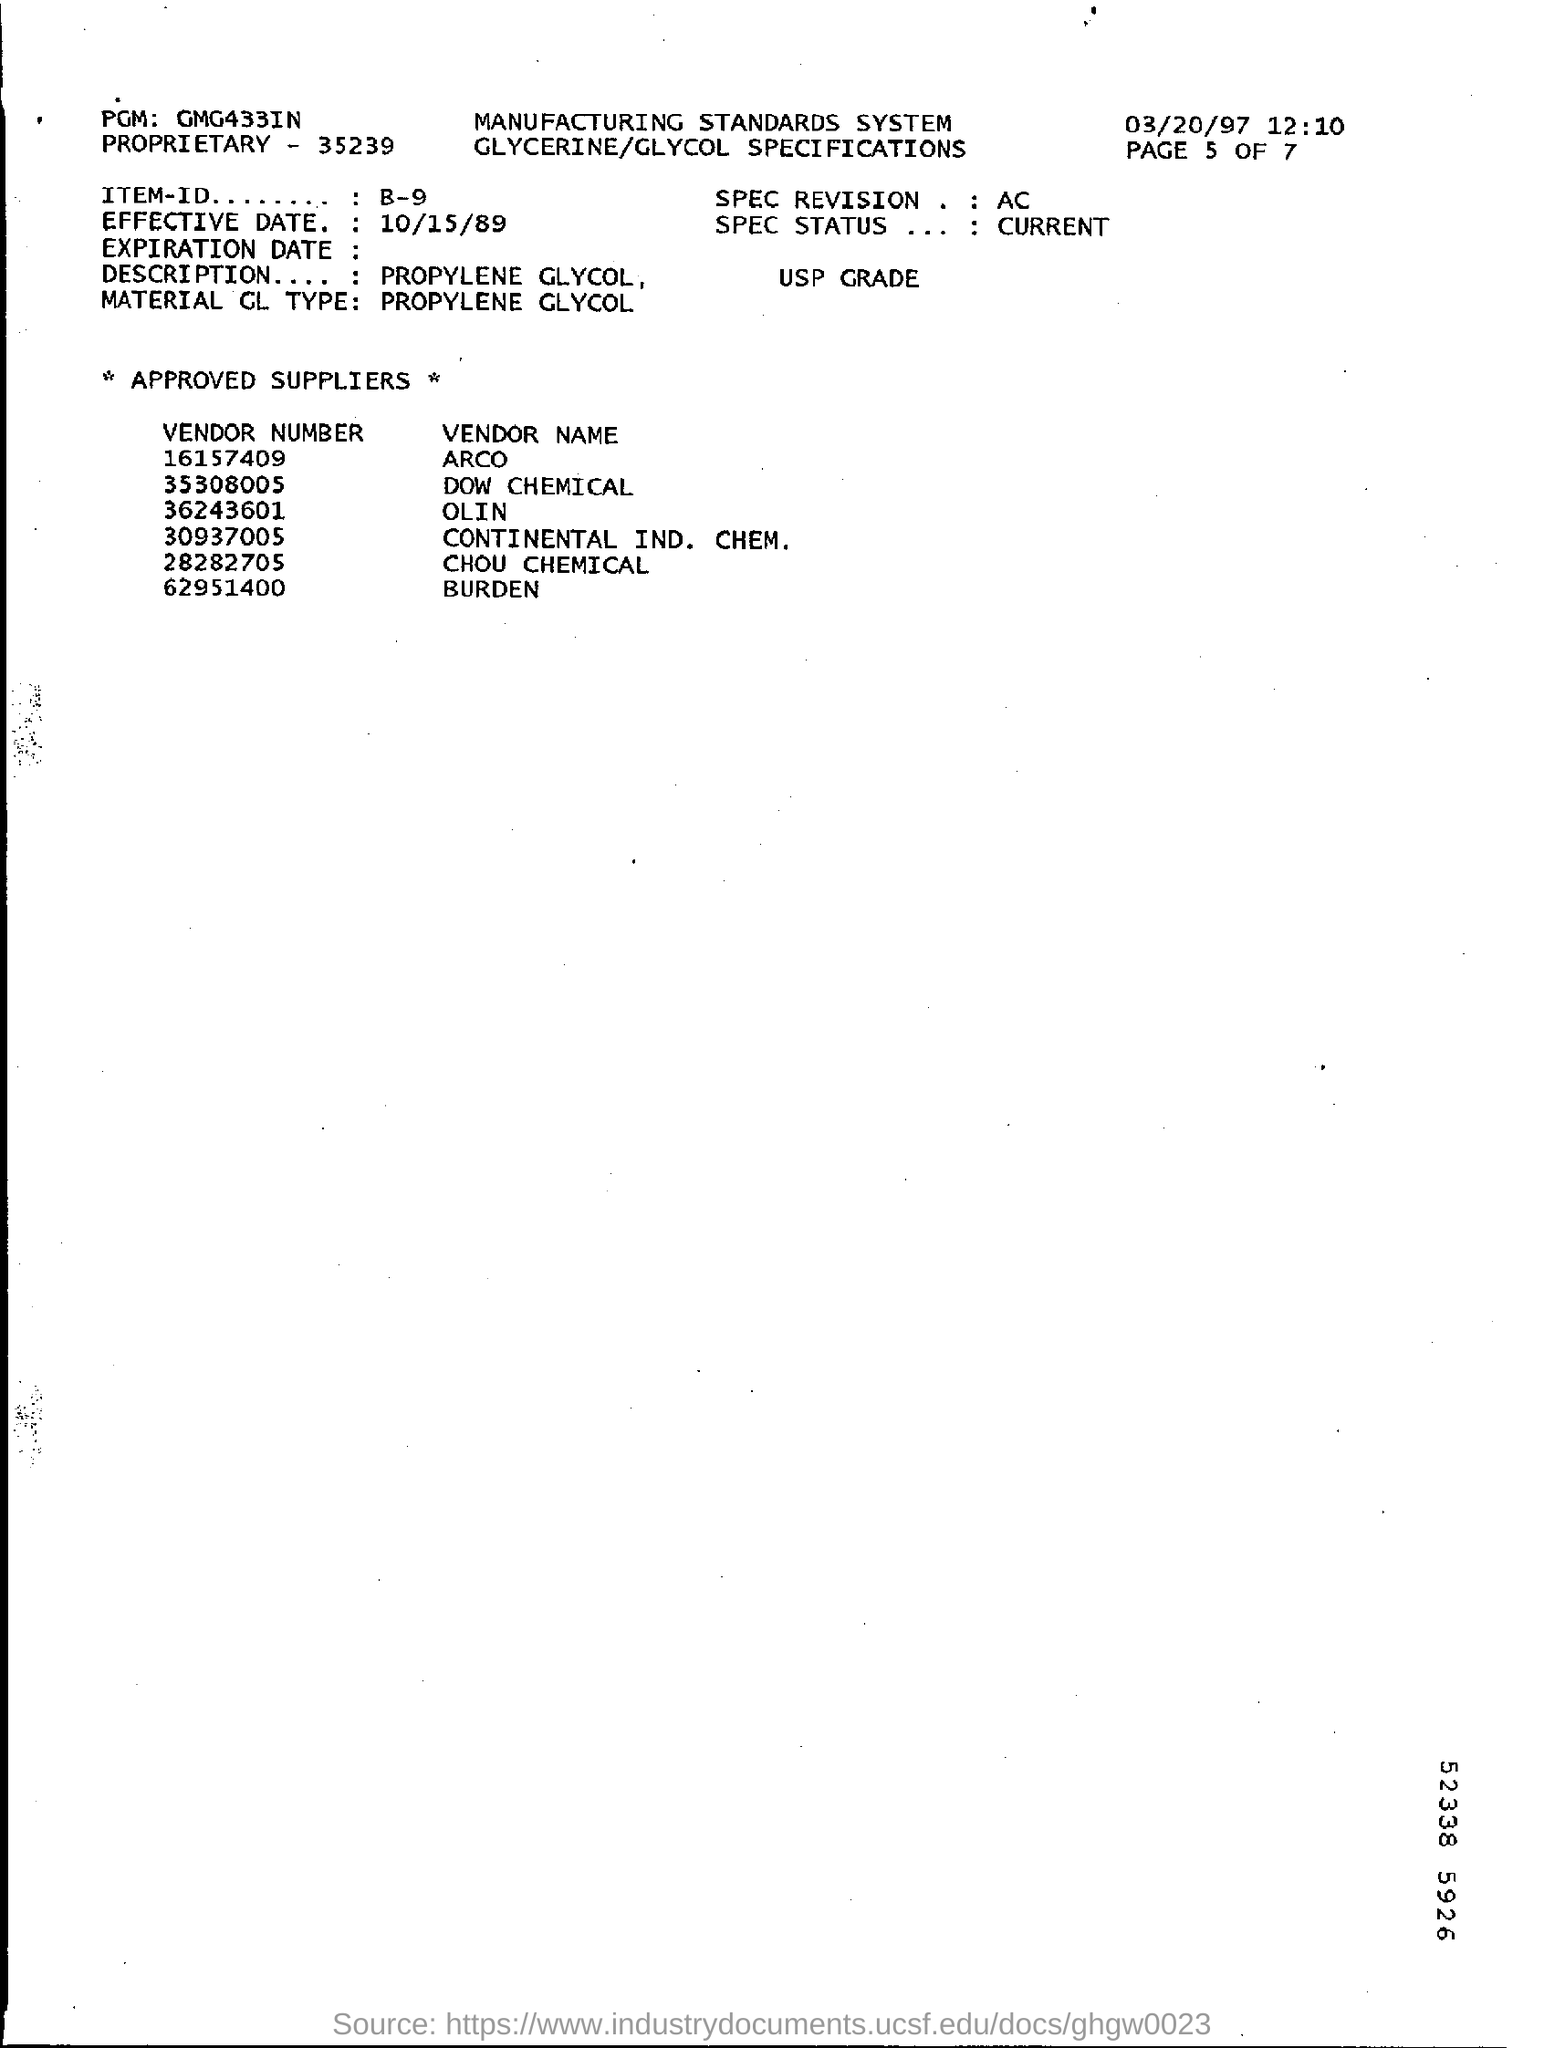What is the effective date?
Your response must be concise. 10/15/89. What is the material GL type?
Provide a succinct answer. Propylene Glycol. What is PGM mentioned?
Make the answer very short. GMG433IN. What is the item id?
Your answer should be very brief. B-9. Who is the vendor corresponding to 62951400?
Offer a very short reply. BURDEN. What is the vendor number of DOW CHEMICAL?
Provide a short and direct response. 35308005. 